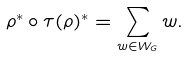Convert formula to latex. <formula><loc_0><loc_0><loc_500><loc_500>\rho ^ { * } \circ \tau ( \rho ) ^ { * } = \sum _ { w \in W _ { G } } w .</formula> 